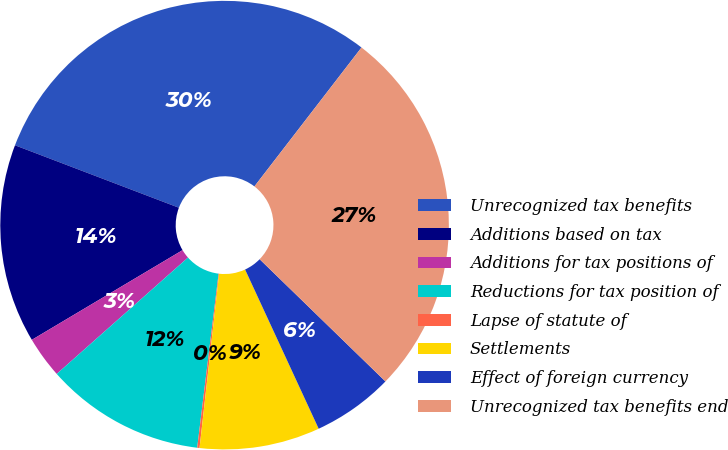<chart> <loc_0><loc_0><loc_500><loc_500><pie_chart><fcel>Unrecognized tax benefits<fcel>Additions based on tax<fcel>Additions for tax positions of<fcel>Reductions for tax position of<fcel>Lapse of statute of<fcel>Settlements<fcel>Effect of foreign currency<fcel>Unrecognized tax benefits end<nl><fcel>29.66%<fcel>14.34%<fcel>3.0%<fcel>11.51%<fcel>0.17%<fcel>8.67%<fcel>5.84%<fcel>26.82%<nl></chart> 